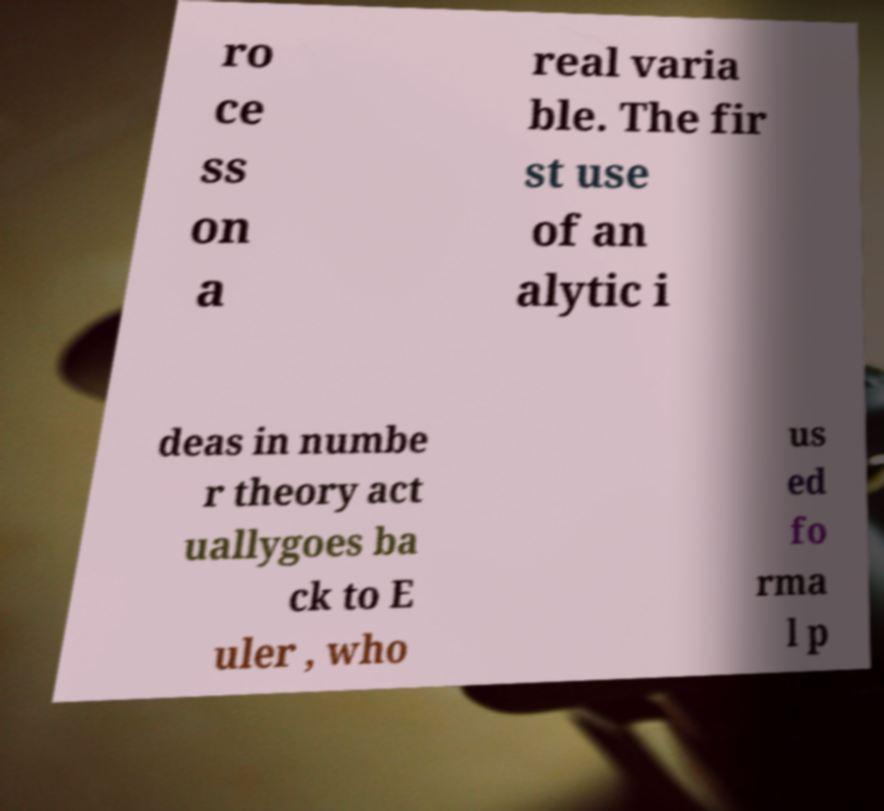Please read and relay the text visible in this image. What does it say? ro ce ss on a real varia ble. The fir st use of an alytic i deas in numbe r theory act uallygoes ba ck to E uler , who us ed fo rma l p 